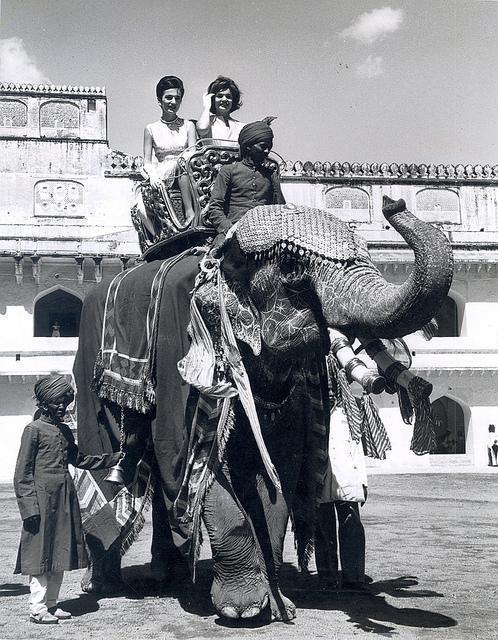How many people can you see?
Give a very brief answer. 5. How many motorcycles have a helmet on the handle bars?
Give a very brief answer. 0. 